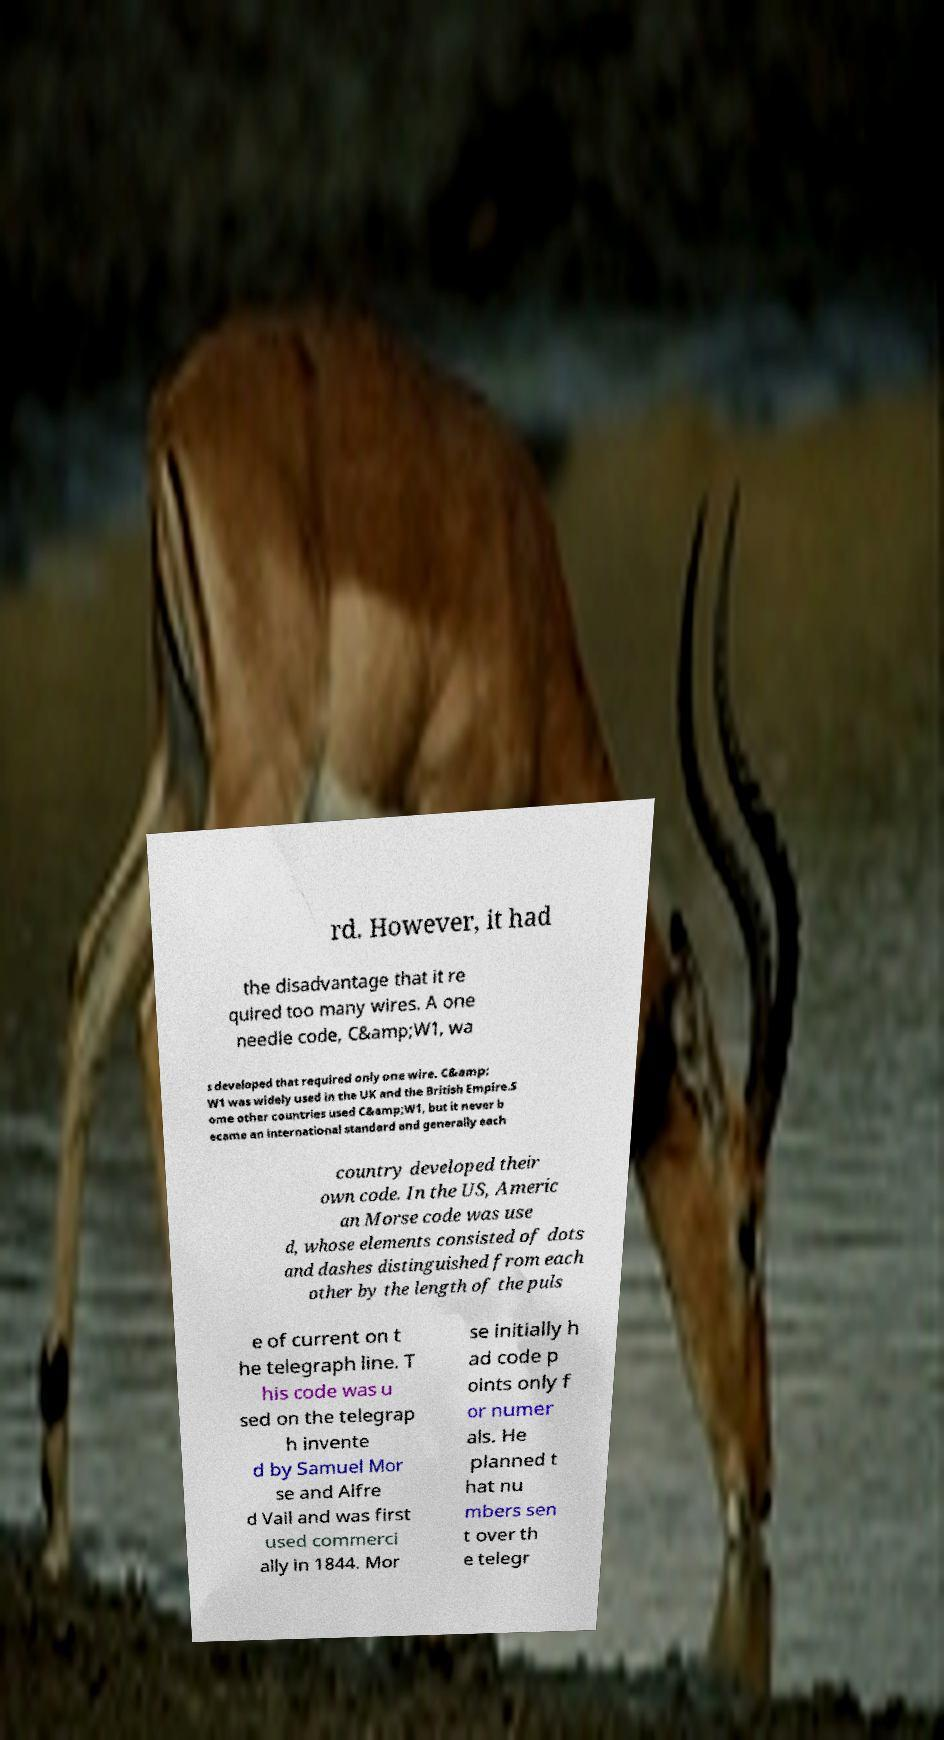I need the written content from this picture converted into text. Can you do that? rd. However, it had the disadvantage that it re quired too many wires. A one needle code, C&amp;W1, wa s developed that required only one wire. C&amp; W1 was widely used in the UK and the British Empire.S ome other countries used C&amp;W1, but it never b ecame an international standard and generally each country developed their own code. In the US, Americ an Morse code was use d, whose elements consisted of dots and dashes distinguished from each other by the length of the puls e of current on t he telegraph line. T his code was u sed on the telegrap h invente d by Samuel Mor se and Alfre d Vail and was first used commerci ally in 1844. Mor se initially h ad code p oints only f or numer als. He planned t hat nu mbers sen t over th e telegr 